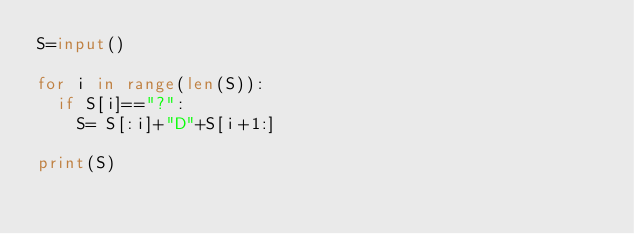Convert code to text. <code><loc_0><loc_0><loc_500><loc_500><_Python_>S=input()

for i in range(len(S)):
  if S[i]=="?":
    S= S[:i]+"D"+S[i+1:]
    
print(S)</code> 